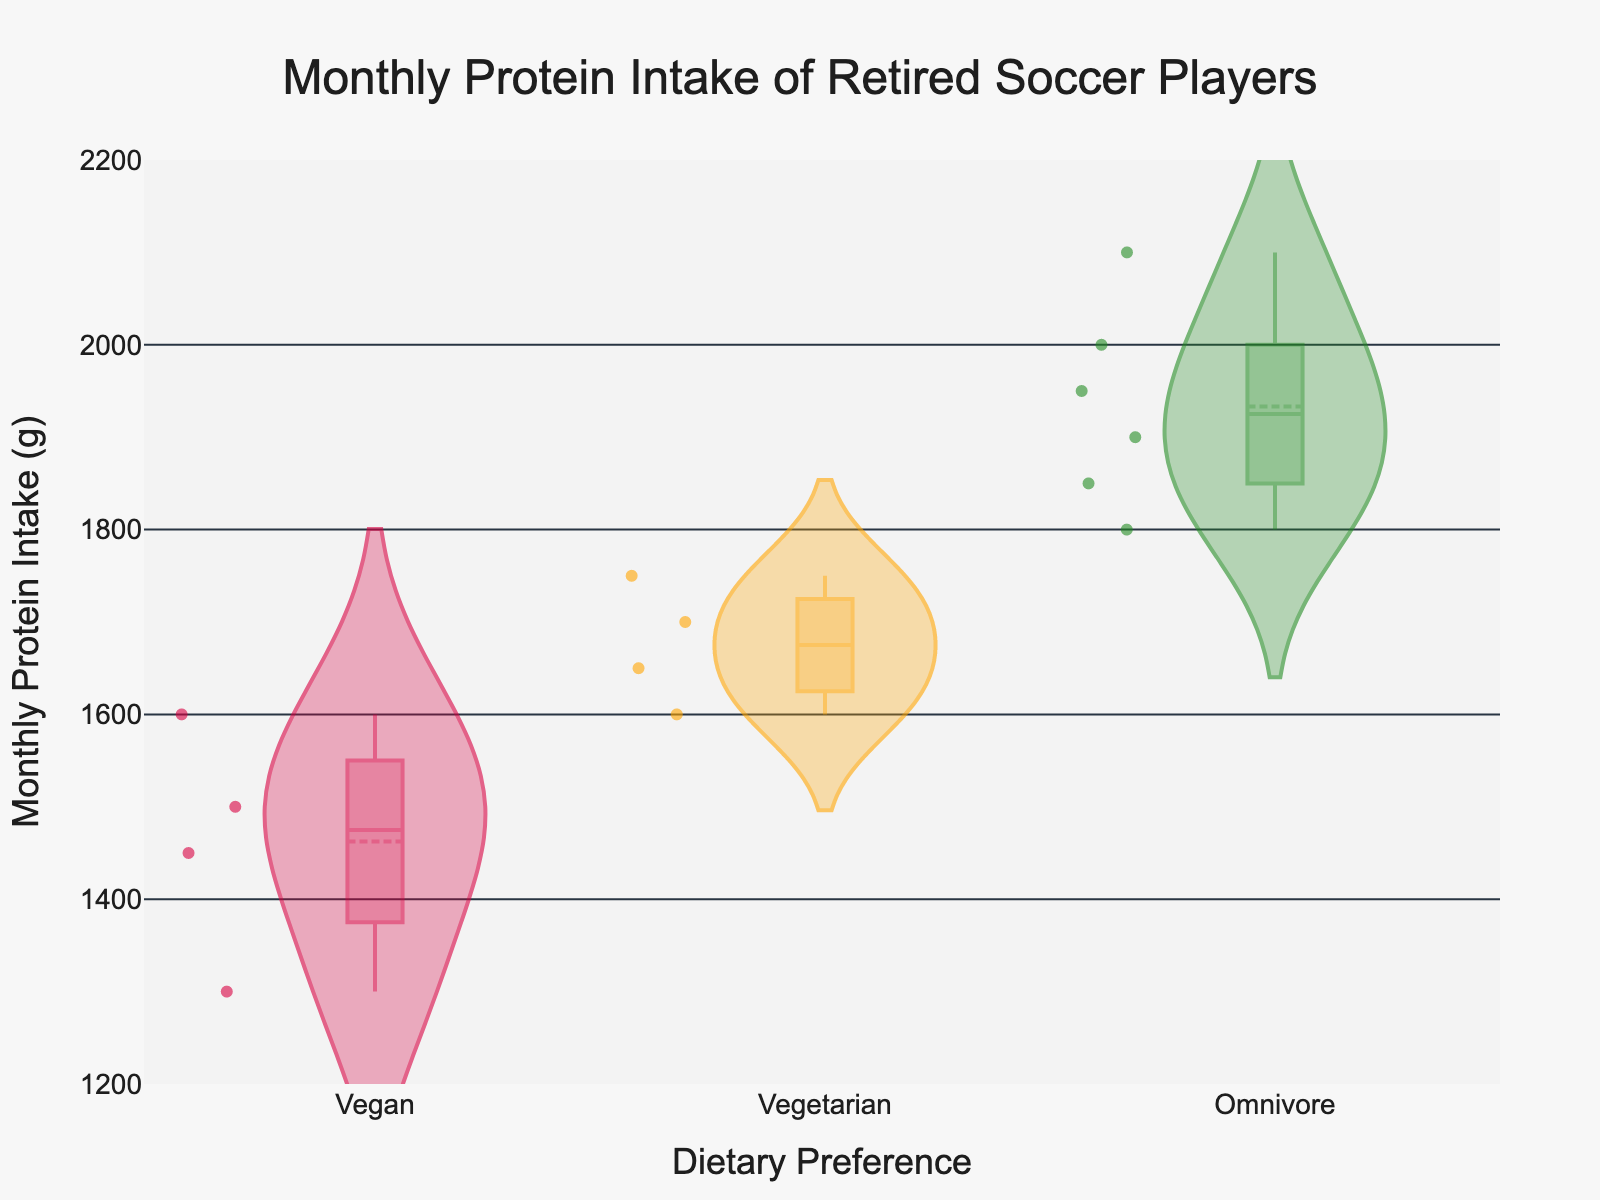What's the title of the figure? The title is located at the top center of the figure and it provides an indication of what the figure represents. In this case, it states: "Monthly Protein Intake of Retired Soccer Players".
Answer: Monthly Protein Intake of Retired Soccer Players What are the dietary preferences shown on the x-axis? The x-axis, usually located at the bottom of the plot, shows the categories being compared. Here, the dietary preferences are "Vegan", "Vegetarian", and "Omnivore".
Answer: Vegan, Vegetarian, Omnivore Which dietary preference has the highest median monthly protein intake? The median is represented by the middle line inside the box in each violin plot. By comparing these lines, the "Omnivore" diet shows the highest median monthly protein intake.
Answer: Omnivore How many individual data points are there for the Vegan dietary preference? In a violin plot, individual data points are often indicated by small dots. By counting these dots for the "Vegan" category, we see there are 4 data points.
Answer: 4 What is the range of monthly protein intake for Vegetarians? The range is the difference between the highest and lowest values. For Vegetarians, the highest value is 1750 g and the lowest is 1600 g, so the range is 1750 g - 1600 g = 150 g.
Answer: 150 g Which dietary preference shows the lowest minimum monthly protein intake and what is this value? The minimum value is represented by the bottom of the violin plot. By observing the lowest point in each category, the Vegan diet has the lowest minimum value, which is 1300 g.
Answer: Vegan, 1300 g What is the average monthly protein intake for the Omnivore dietary preference? The average can be approximated by locating the mean line in the Omnivore violin plot. The mean is 1930 g, as indicated by the mean line shown in the violin plot for Omnivores.
Answer: 1930 g Which dietary preference has the most spread in monthly protein intake values? Spread refers to how extended the data values are on the y-axis. The "Omnivore" plot appears to have the widest spread from about 1800 g to 2100 g, indicating higher variability in protein intake.
Answer: Omnivore Do Vegans have any monthly protein intake values above 1600 g? By looking at the upper part of the Vegan violin plot, we can see that there are no data points or areas extending above 1600 g.
Answer: No What color is used to represent the Vegetarian dietary preference in the plot? The Vegetarian dietary preference is shown using the middle color, which is orange.
Answer: Orange 